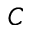<formula> <loc_0><loc_0><loc_500><loc_500>C</formula> 